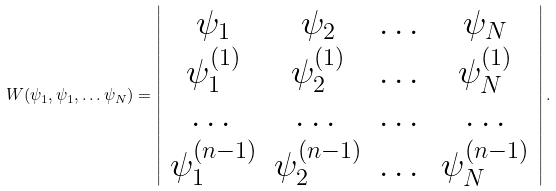<formula> <loc_0><loc_0><loc_500><loc_500>W ( \psi _ { 1 } , \psi _ { 1 } , \dots \psi _ { N } ) = \left | \begin{array} { c c c c } \psi _ { 1 } & \psi _ { 2 } & \dots & \psi _ { N } \\ \psi _ { 1 } ^ { ( 1 ) } & \psi _ { 2 } ^ { ( 1 ) } & \dots & \psi _ { N } ^ { ( 1 ) } \\ \dots & \dots & \dots & \dots \\ \psi _ { 1 } ^ { ( n - 1 ) } & \psi _ { 2 } ^ { ( n - 1 ) } & \dots & \psi _ { N } ^ { ( n - 1 ) } \end{array} \right | .</formula> 